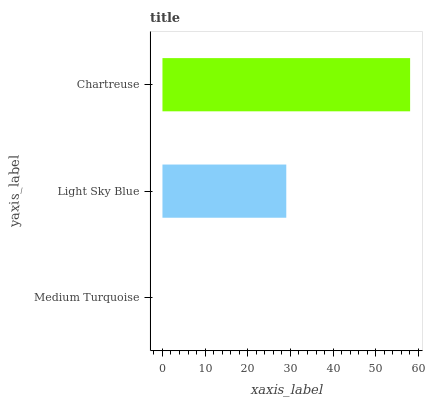Is Medium Turquoise the minimum?
Answer yes or no. Yes. Is Chartreuse the maximum?
Answer yes or no. Yes. Is Light Sky Blue the minimum?
Answer yes or no. No. Is Light Sky Blue the maximum?
Answer yes or no. No. Is Light Sky Blue greater than Medium Turquoise?
Answer yes or no. Yes. Is Medium Turquoise less than Light Sky Blue?
Answer yes or no. Yes. Is Medium Turquoise greater than Light Sky Blue?
Answer yes or no. No. Is Light Sky Blue less than Medium Turquoise?
Answer yes or no. No. Is Light Sky Blue the high median?
Answer yes or no. Yes. Is Light Sky Blue the low median?
Answer yes or no. Yes. Is Medium Turquoise the high median?
Answer yes or no. No. Is Chartreuse the low median?
Answer yes or no. No. 